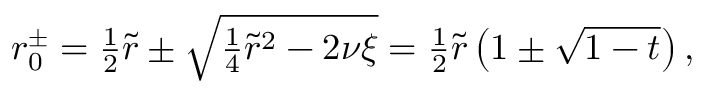<formula> <loc_0><loc_0><loc_500><loc_500>\begin{array} { r } { r _ { 0 } ^ { \pm } = \frac { 1 } { 2 } \tilde { r } \pm \sqrt { \frac { 1 } { 4 } \tilde { r } ^ { 2 } - 2 \nu \xi } = \frac { 1 } { 2 } \tilde { r } \left ( 1 \pm \sqrt { 1 - t } \right ) , } \end{array}</formula> 